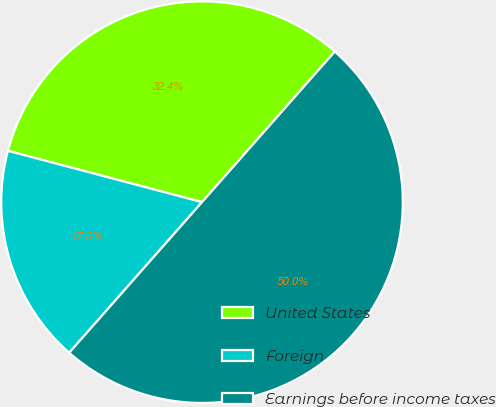<chart> <loc_0><loc_0><loc_500><loc_500><pie_chart><fcel>United States<fcel>Foreign<fcel>Earnings before income taxes<nl><fcel>32.39%<fcel>17.61%<fcel>50.0%<nl></chart> 